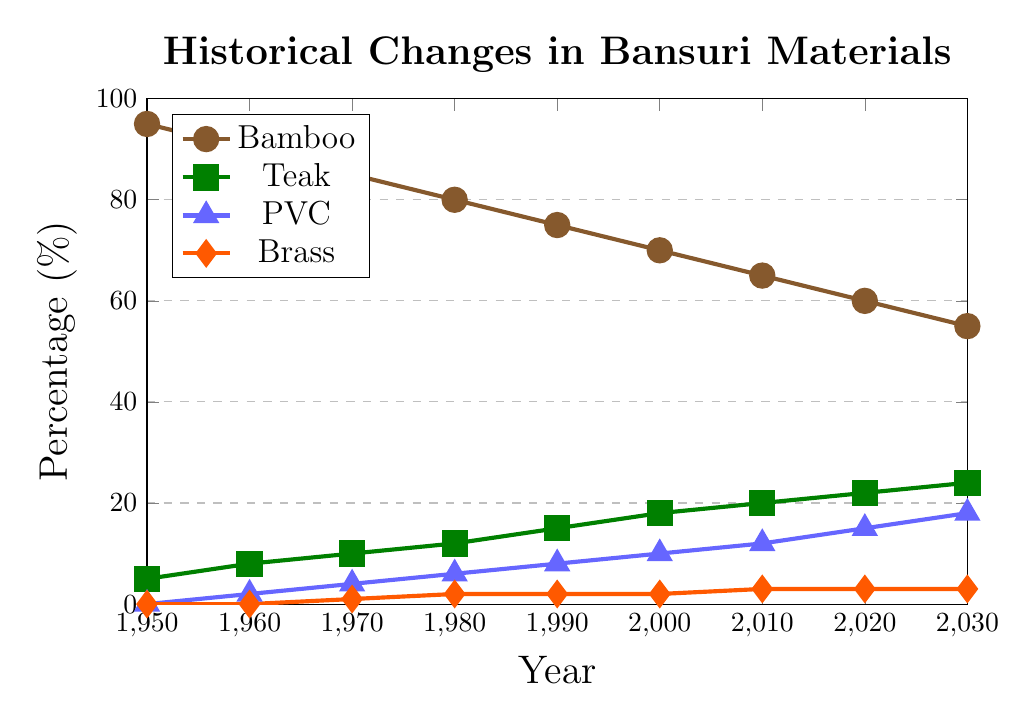What material had the highest percentage usage in 1950? By looking at the figure's lines at the 1950 mark, we see that the brown line representing Bamboo is at the highest point.
Answer: Bamboo How much did the usage of PVC increase from 1950 to 2030? The PVC usage in 1950 was 0%, and in 2030 it is 18%. The increase is 18% - 0% = 18%.
Answer: 18% Which year did Brass usage first exceed 2%? By following the orange line representing Brass, we see that it first exceeds 2% in the year 2000.
Answer: 2000 What's the total percentage of usage for all materials in 1990? In 1990, Bamboo is 75%, Teak is 15%, PVC is 8%, and Brass is 2%. The total is 75% + 15% + 8% + 2% = 100%.
Answer: 100% In which decade did Teak usage see the highest increase? By examining the green line, we see the largest increase from one decade to the next between 1990 (15%) and 2000 (18%), an increase of 3%.
Answer: 1990-2000 Which material is consistently increasing in usage? By looking at the trend lines, Teak and PVC show consistent increases over the years.
Answer: Teak and PVC How does Bamboo's decreasing trend compare to PVC's increasing trend? While Bamboo steadily decreases from 95% in 1950 to 55% in 2030, PVC steadily increases from 0% in 1950 to 18% in 2030. Both show consistent trends in opposite directions.
Answer: Opposite consistent trends In which year does the usage of Bamboo drop to 60%? Referencing the brown line for Bamboo, it drops to 60% in the year 2020.
Answer: 2020 How did the usage percentages of Teak and PVC compare in 1980? In 1980, Teak usage is 12%, and PVC usage is 6%. Teak usage is double that of PVC.
Answer: Teak double PVC What is the average percentage usage of Brass from 1970 to 2030? Brass percentages are: 1%, 2%, 2%, 2%, 3%, 3%, 3%. Sum is 16% (1+2+2+2+3+3+3), and there are 7 data points. So the average is 16% / 7 ≈ 2.29%.
Answer: 2.29% 